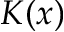<formula> <loc_0><loc_0><loc_500><loc_500>K ( x )</formula> 